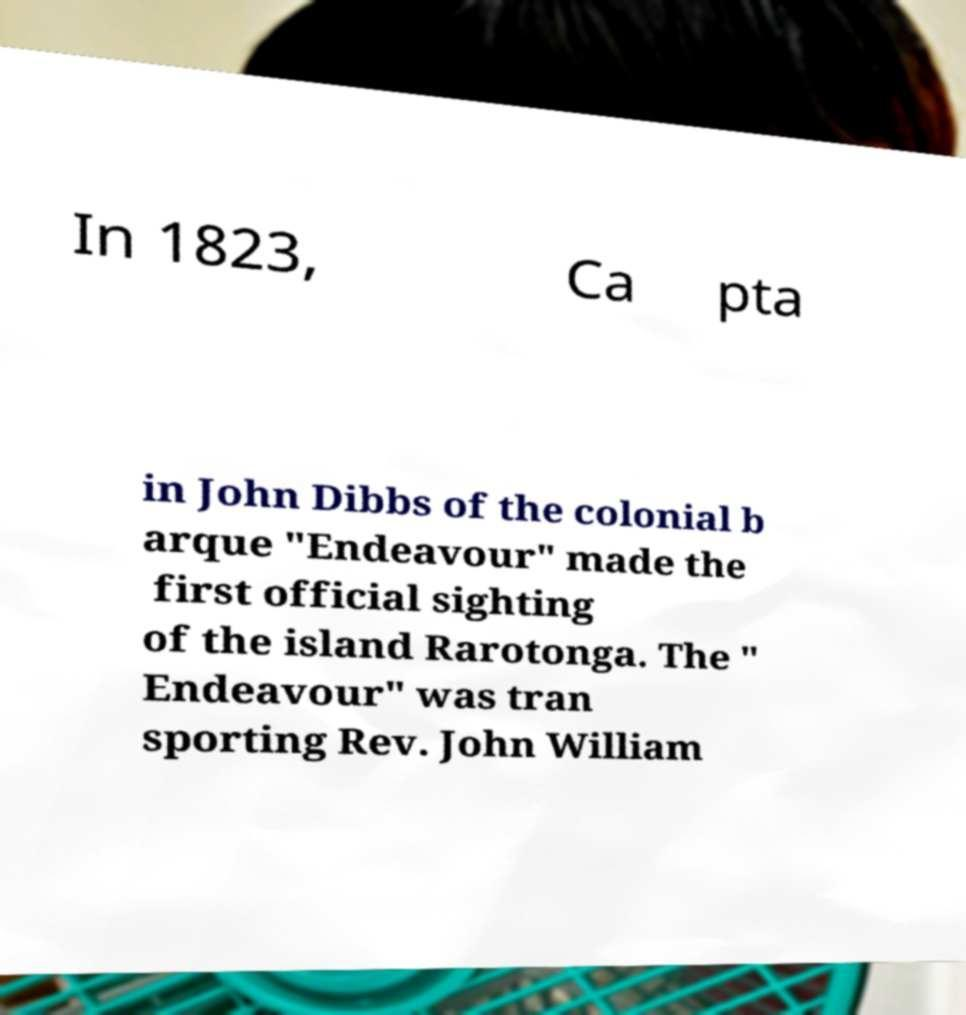Please read and relay the text visible in this image. What does it say? In 1823, Ca pta in John Dibbs of the colonial b arque "Endeavour" made the first official sighting of the island Rarotonga. The " Endeavour" was tran sporting Rev. John William 